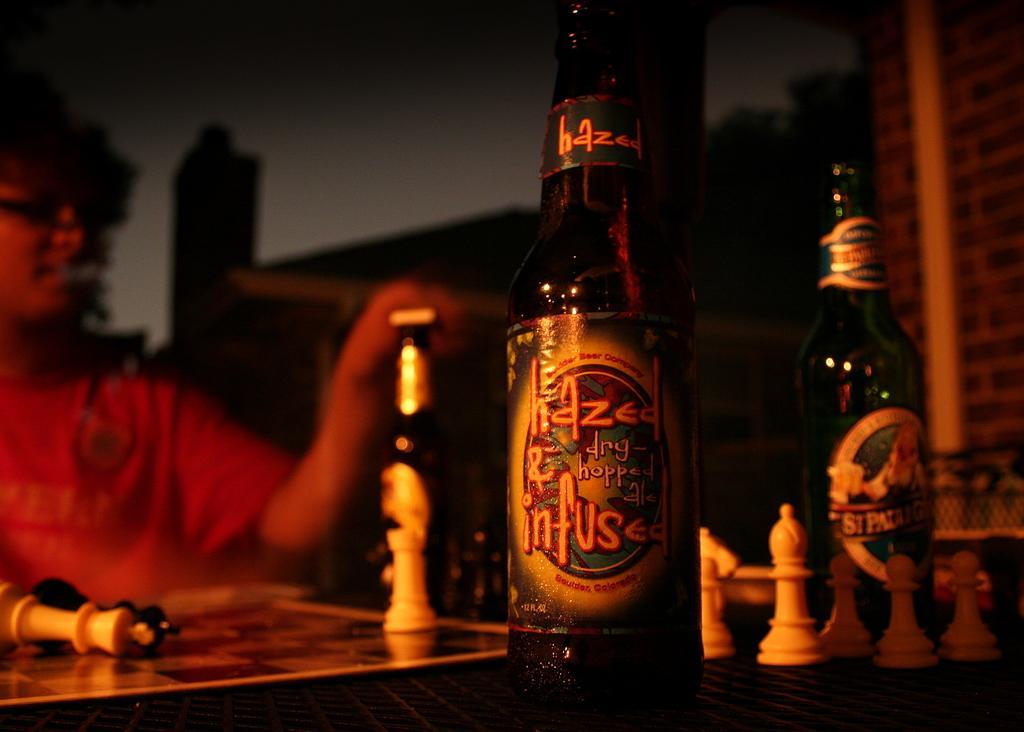Describe this image in one or two sentences. In this picture we can see a person, chess board and chess pieces. We can see bottles. Background portion of the picture is blurry and dark. 